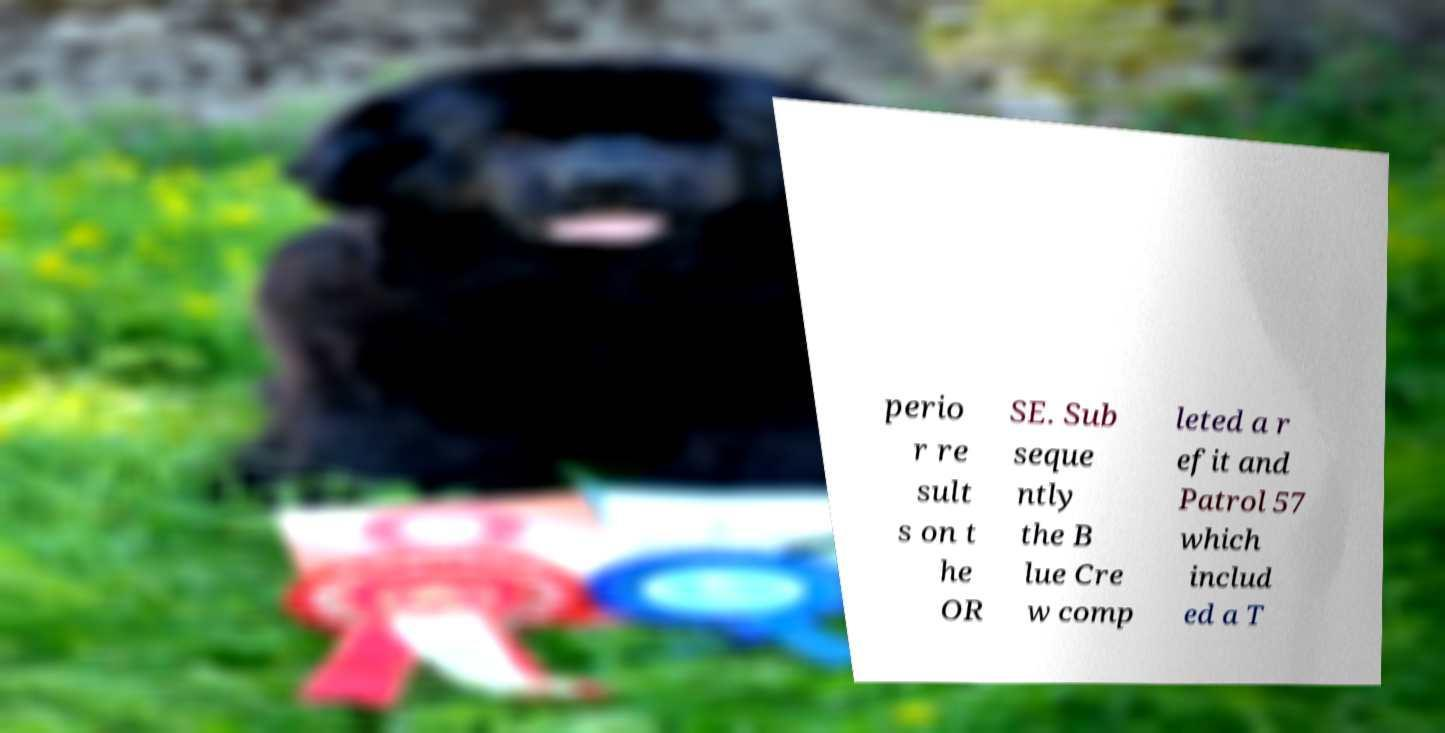Can you accurately transcribe the text from the provided image for me? perio r re sult s on t he OR SE. Sub seque ntly the B lue Cre w comp leted a r efit and Patrol 57 which includ ed a T 